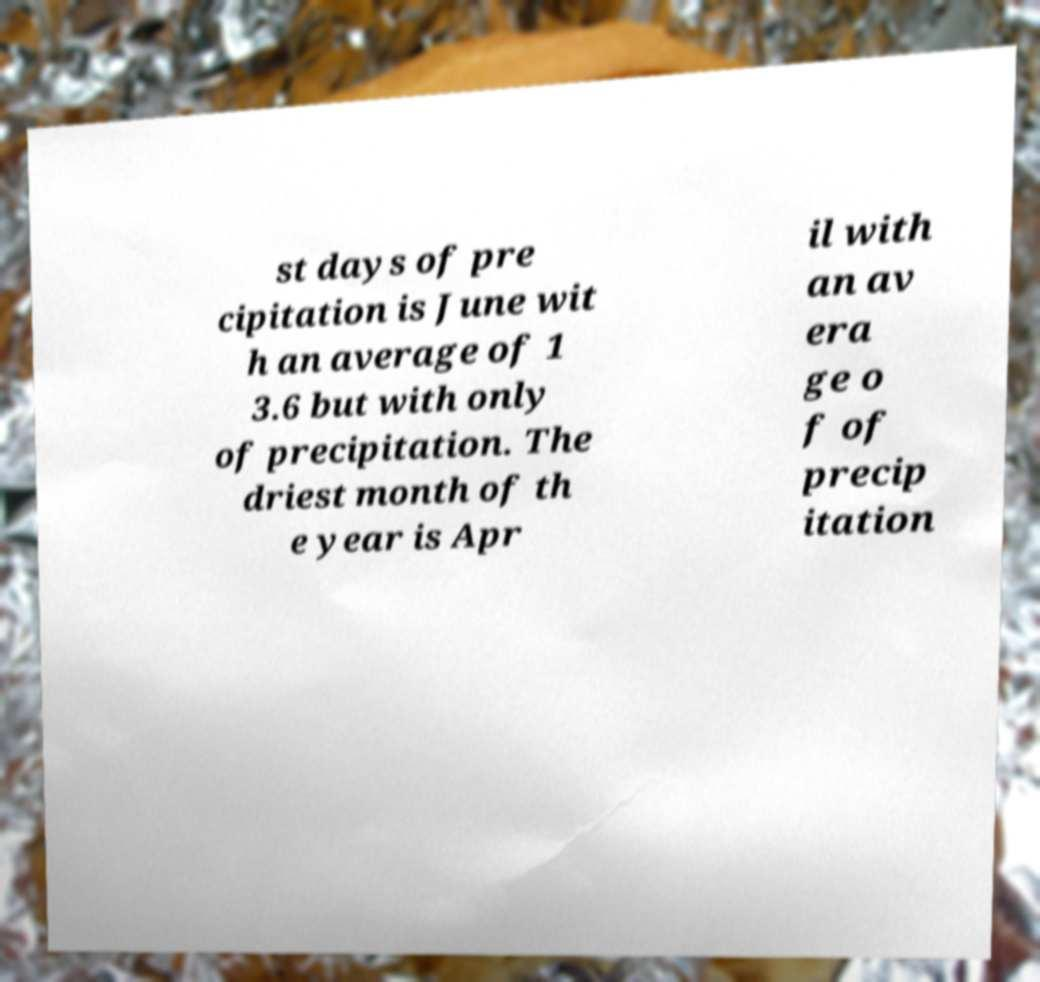Please read and relay the text visible in this image. What does it say? st days of pre cipitation is June wit h an average of 1 3.6 but with only of precipitation. The driest month of th e year is Apr il with an av era ge o f of precip itation 